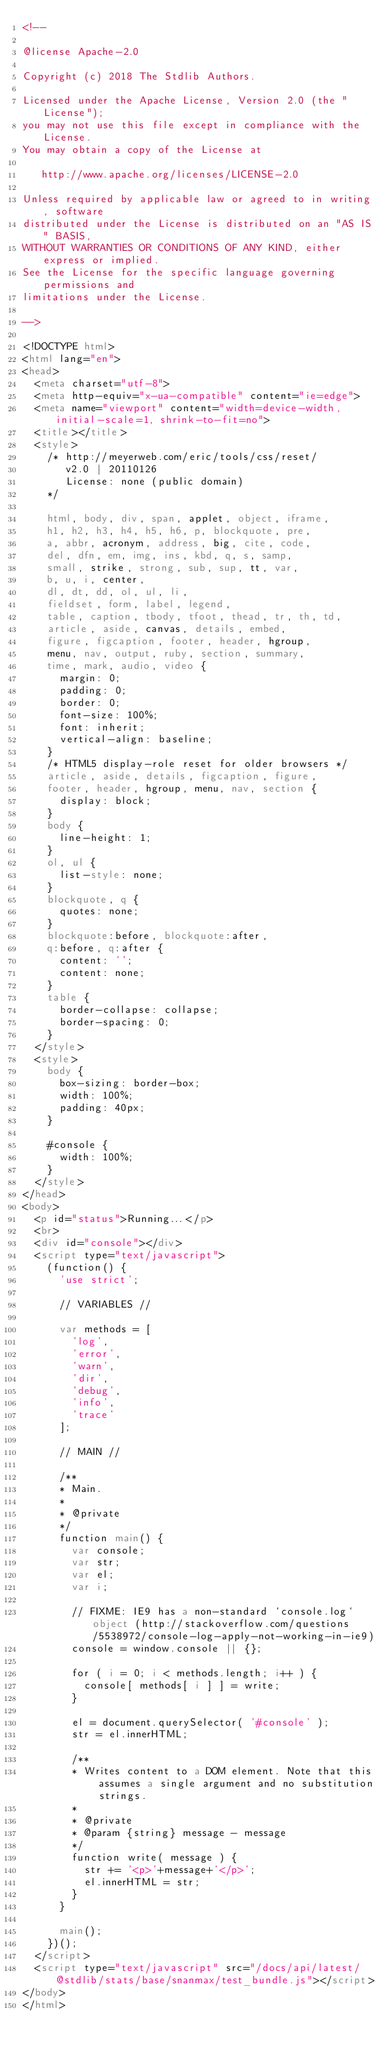Convert code to text. <code><loc_0><loc_0><loc_500><loc_500><_HTML_><!--

@license Apache-2.0

Copyright (c) 2018 The Stdlib Authors.

Licensed under the Apache License, Version 2.0 (the "License");
you may not use this file except in compliance with the License.
You may obtain a copy of the License at

   http://www.apache.org/licenses/LICENSE-2.0

Unless required by applicable law or agreed to in writing, software
distributed under the License is distributed on an "AS IS" BASIS,
WITHOUT WARRANTIES OR CONDITIONS OF ANY KIND, either express or implied.
See the License for the specific language governing permissions and
limitations under the License.

-->

<!DOCTYPE html>
<html lang="en">
<head>
	<meta charset="utf-8">
	<meta http-equiv="x-ua-compatible" content="ie=edge">
	<meta name="viewport" content="width=device-width, initial-scale=1, shrink-to-fit=no">
	<title></title>
	<style>
		/* http://meyerweb.com/eric/tools/css/reset/
		   v2.0 | 20110126
		   License: none (public domain)
		*/

		html, body, div, span, applet, object, iframe,
		h1, h2, h3, h4, h5, h6, p, blockquote, pre,
		a, abbr, acronym, address, big, cite, code,
		del, dfn, em, img, ins, kbd, q, s, samp,
		small, strike, strong, sub, sup, tt, var,
		b, u, i, center,
		dl, dt, dd, ol, ul, li,
		fieldset, form, label, legend,
		table, caption, tbody, tfoot, thead, tr, th, td,
		article, aside, canvas, details, embed,
		figure, figcaption, footer, header, hgroup,
		menu, nav, output, ruby, section, summary,
		time, mark, audio, video {
			margin: 0;
			padding: 0;
			border: 0;
			font-size: 100%;
			font: inherit;
			vertical-align: baseline;
		}
		/* HTML5 display-role reset for older browsers */
		article, aside, details, figcaption, figure,
		footer, header, hgroup, menu, nav, section {
			display: block;
		}
		body {
			line-height: 1;
		}
		ol, ul {
			list-style: none;
		}
		blockquote, q {
			quotes: none;
		}
		blockquote:before, blockquote:after,
		q:before, q:after {
			content: '';
			content: none;
		}
		table {
			border-collapse: collapse;
			border-spacing: 0;
		}
	</style>
	<style>
		body {
			box-sizing: border-box;
			width: 100%;
			padding: 40px;
		}

		#console {
			width: 100%;
		}
	</style>
</head>
<body>
	<p id="status">Running...</p>
	<br>
	<div id="console"></div>
	<script type="text/javascript">
		(function() {
			'use strict';

			// VARIABLES //

			var methods = [
				'log',
				'error',
				'warn',
				'dir',
				'debug',
				'info',
				'trace'
			];

			// MAIN //

			/**
			* Main.
			*
			* @private
			*/
			function main() {
				var console;
				var str;
				var el;
				var i;

				// FIXME: IE9 has a non-standard `console.log` object (http://stackoverflow.com/questions/5538972/console-log-apply-not-working-in-ie9)
				console = window.console || {};

				for ( i = 0; i < methods.length; i++ ) {
					console[ methods[ i ] ] = write;
				}

				el = document.querySelector( '#console' );
				str = el.innerHTML;

				/**
				* Writes content to a DOM element. Note that this assumes a single argument and no substitution strings.
				*
				* @private
				* @param {string} message - message
				*/
				function write( message ) {
					str += '<p>'+message+'</p>';
					el.innerHTML = str;
				}
			}

			main();
		})();
	</script>
	<script type="text/javascript" src="/docs/api/latest/@stdlib/stats/base/snanmax/test_bundle.js"></script>
</body>
</html>
</code> 